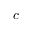Convert formula to latex. <formula><loc_0><loc_0><loc_500><loc_500>c</formula> 